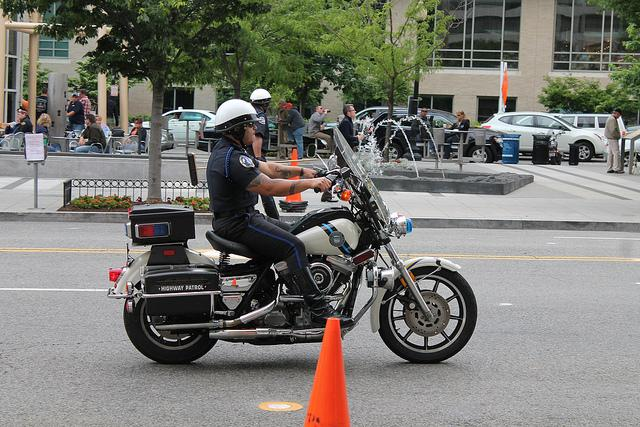Where is the officer riding here? Please explain your reasoning. parade route. There are traffic cones that are being set up or taken down without any road work being done, with one officer on a motorcycle and one walking. 